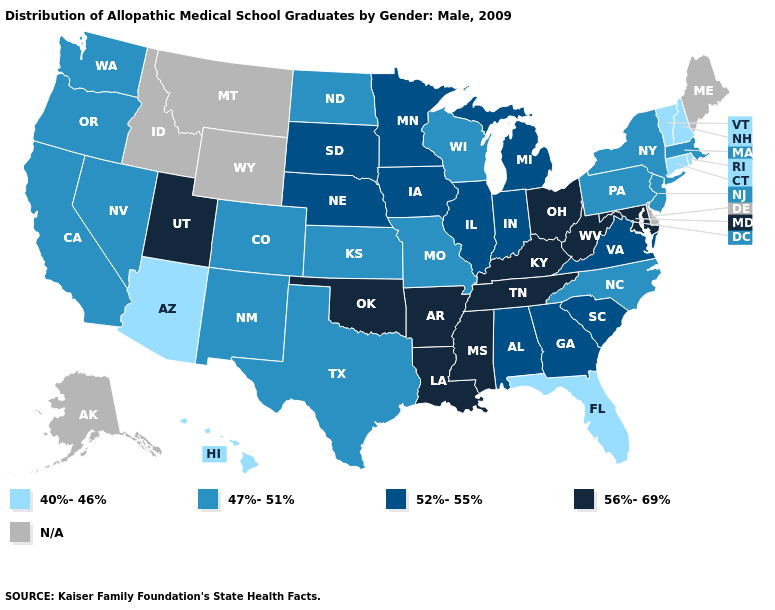What is the lowest value in the South?
Answer briefly. 40%-46%. Name the states that have a value in the range 40%-46%?
Keep it brief. Arizona, Connecticut, Florida, Hawaii, New Hampshire, Rhode Island, Vermont. What is the value of New York?
Answer briefly. 47%-51%. Does North Dakota have the lowest value in the MidWest?
Give a very brief answer. Yes. Name the states that have a value in the range N/A?
Answer briefly. Alaska, Delaware, Idaho, Maine, Montana, Wyoming. What is the value of Iowa?
Concise answer only. 52%-55%. Name the states that have a value in the range 47%-51%?
Be succinct. California, Colorado, Kansas, Massachusetts, Missouri, Nevada, New Jersey, New Mexico, New York, North Carolina, North Dakota, Oregon, Pennsylvania, Texas, Washington, Wisconsin. What is the highest value in the MidWest ?
Keep it brief. 56%-69%. Among the states that border Montana , which have the highest value?
Concise answer only. South Dakota. 